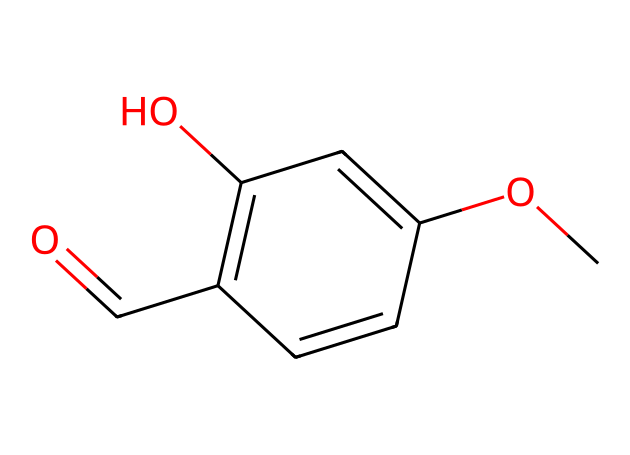How many carbon atoms are in vanillin? Counting the carbon (C) atoms in the SMILES representation, we can see there are 8 carbon atoms.
Answer: 8 What is the functional group present in vanillin? The functional group is identified by looking for the specific structure that contains a carbonyl (C=O) directly attached to a carbon atom which also has a hydrogen atom (aldehyde). In this case, the functional group is –CHO.
Answer: aldehyde How many oxygen atoms are in the structure of vanillin? By examining the SMILES, we find two oxygen (O) atoms are present; one in the carbonyl group and another in the methoxy group (–OCH3).
Answer: 2 What is the role of the aldehyde functional group in vanillin? The aldehyde functional group contributes to the characteristic aroma of vanilla, as it is responsible for the sweet scent commonly associated with vanilla flavoring.
Answer: aroma Which type of compound is vanillin classified as? Vanillin is classified by the presence of the aromatic ring and the functional groups present, indicating it is a phenolic aldehyde.
Answer: phenolic aldehyde How many pi bonds are present in vanillin? By analyzing the double bonds in the structure, there are three pi bonds present in vanillin: one in the aldehyde and two in the aromatic ring system.
Answer: 3 What imparting feature of the structure makes vanillin soluble in water? The presence of the hydroxyl group (–OH) and the aldehyde group allow for hydrogen bonding with water molecules, making vanillin soluble.
Answer: hydrogen bonding 